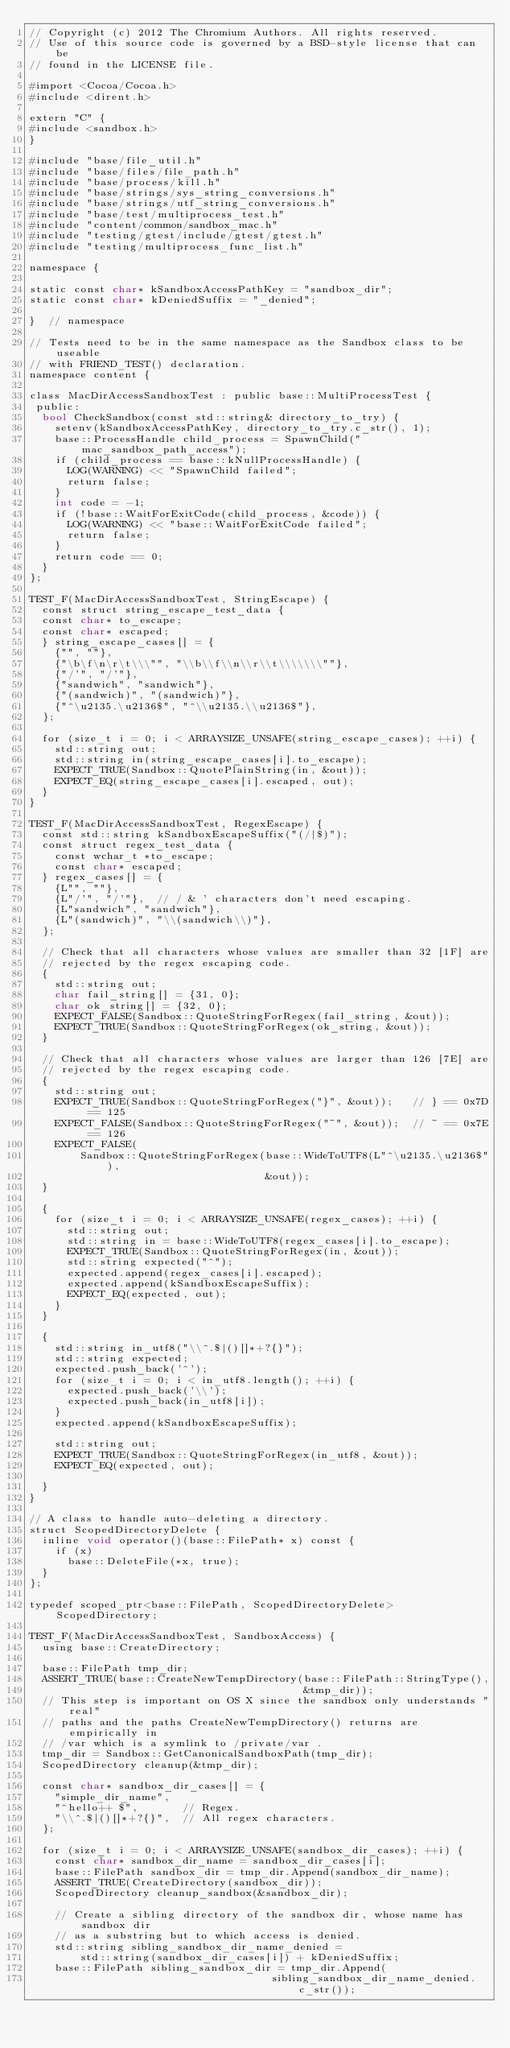Convert code to text. <code><loc_0><loc_0><loc_500><loc_500><_ObjectiveC_>// Copyright (c) 2012 The Chromium Authors. All rights reserved.
// Use of this source code is governed by a BSD-style license that can be
// found in the LICENSE file.

#import <Cocoa/Cocoa.h>
#include <dirent.h>

extern "C" {
#include <sandbox.h>
}

#include "base/file_util.h"
#include "base/files/file_path.h"
#include "base/process/kill.h"
#include "base/strings/sys_string_conversions.h"
#include "base/strings/utf_string_conversions.h"
#include "base/test/multiprocess_test.h"
#include "content/common/sandbox_mac.h"
#include "testing/gtest/include/gtest/gtest.h"
#include "testing/multiprocess_func_list.h"

namespace {

static const char* kSandboxAccessPathKey = "sandbox_dir";
static const char* kDeniedSuffix = "_denied";

}  // namespace

// Tests need to be in the same namespace as the Sandbox class to be useable
// with FRIEND_TEST() declaration.
namespace content {

class MacDirAccessSandboxTest : public base::MultiProcessTest {
 public:
  bool CheckSandbox(const std::string& directory_to_try) {
    setenv(kSandboxAccessPathKey, directory_to_try.c_str(), 1);
    base::ProcessHandle child_process = SpawnChild("mac_sandbox_path_access");
    if (child_process == base::kNullProcessHandle) {
      LOG(WARNING) << "SpawnChild failed";
      return false;
    }
    int code = -1;
    if (!base::WaitForExitCode(child_process, &code)) {
      LOG(WARNING) << "base::WaitForExitCode failed";
      return false;
    }
    return code == 0;
  }
};

TEST_F(MacDirAccessSandboxTest, StringEscape) {
  const struct string_escape_test_data {
  const char* to_escape;
  const char* escaped;
  } string_escape_cases[] = {
    {"", ""},
    {"\b\f\n\r\t\\\"", "\\b\\f\\n\\r\\t\\\\\\\""},
    {"/'", "/'"},
    {"sandwich", "sandwich"},
    {"(sandwich)", "(sandwich)"},
    {"^\u2135.\u2136$", "^\\u2135.\\u2136$"},
  };

  for (size_t i = 0; i < ARRAYSIZE_UNSAFE(string_escape_cases); ++i) {
    std::string out;
    std::string in(string_escape_cases[i].to_escape);
    EXPECT_TRUE(Sandbox::QuotePlainString(in, &out));
    EXPECT_EQ(string_escape_cases[i].escaped, out);
  }
}

TEST_F(MacDirAccessSandboxTest, RegexEscape) {
  const std::string kSandboxEscapeSuffix("(/|$)");
  const struct regex_test_data {
    const wchar_t *to_escape;
    const char* escaped;
  } regex_cases[] = {
    {L"", ""},
    {L"/'", "/'"},  // / & ' characters don't need escaping.
    {L"sandwich", "sandwich"},
    {L"(sandwich)", "\\(sandwich\\)"},
  };

  // Check that all characters whose values are smaller than 32 [1F] are
  // rejected by the regex escaping code.
  {
    std::string out;
    char fail_string[] = {31, 0};
    char ok_string[] = {32, 0};
    EXPECT_FALSE(Sandbox::QuoteStringForRegex(fail_string, &out));
    EXPECT_TRUE(Sandbox::QuoteStringForRegex(ok_string, &out));
  }

  // Check that all characters whose values are larger than 126 [7E] are
  // rejected by the regex escaping code.
  {
    std::string out;
    EXPECT_TRUE(Sandbox::QuoteStringForRegex("}", &out));   // } == 0x7D == 125
    EXPECT_FALSE(Sandbox::QuoteStringForRegex("~", &out));  // ~ == 0x7E == 126
    EXPECT_FALSE(
        Sandbox::QuoteStringForRegex(base::WideToUTF8(L"^\u2135.\u2136$"),
                                     &out));
  }

  {
    for (size_t i = 0; i < ARRAYSIZE_UNSAFE(regex_cases); ++i) {
      std::string out;
      std::string in = base::WideToUTF8(regex_cases[i].to_escape);
      EXPECT_TRUE(Sandbox::QuoteStringForRegex(in, &out));
      std::string expected("^");
      expected.append(regex_cases[i].escaped);
      expected.append(kSandboxEscapeSuffix);
      EXPECT_EQ(expected, out);
    }
  }

  {
    std::string in_utf8("\\^.$|()[]*+?{}");
    std::string expected;
    expected.push_back('^');
    for (size_t i = 0; i < in_utf8.length(); ++i) {
      expected.push_back('\\');
      expected.push_back(in_utf8[i]);
    }
    expected.append(kSandboxEscapeSuffix);

    std::string out;
    EXPECT_TRUE(Sandbox::QuoteStringForRegex(in_utf8, &out));
    EXPECT_EQ(expected, out);

  }
}

// A class to handle auto-deleting a directory.
struct ScopedDirectoryDelete {
  inline void operator()(base::FilePath* x) const {
    if (x)
      base::DeleteFile(*x, true);
  }
};

typedef scoped_ptr<base::FilePath, ScopedDirectoryDelete> ScopedDirectory;

TEST_F(MacDirAccessSandboxTest, SandboxAccess) {
  using base::CreateDirectory;

  base::FilePath tmp_dir;
  ASSERT_TRUE(base::CreateNewTempDirectory(base::FilePath::StringType(),
                                           &tmp_dir));
  // This step is important on OS X since the sandbox only understands "real"
  // paths and the paths CreateNewTempDirectory() returns are empirically in
  // /var which is a symlink to /private/var .
  tmp_dir = Sandbox::GetCanonicalSandboxPath(tmp_dir);
  ScopedDirectory cleanup(&tmp_dir);

  const char* sandbox_dir_cases[] = {
    "simple_dir_name",
    "^hello++ $",       // Regex.
    "\\^.$|()[]*+?{}",  // All regex characters.
  };

  for (size_t i = 0; i < ARRAYSIZE_UNSAFE(sandbox_dir_cases); ++i) {
    const char* sandbox_dir_name = sandbox_dir_cases[i];
    base::FilePath sandbox_dir = tmp_dir.Append(sandbox_dir_name);
    ASSERT_TRUE(CreateDirectory(sandbox_dir));
    ScopedDirectory cleanup_sandbox(&sandbox_dir);

    // Create a sibling directory of the sandbox dir, whose name has sandbox dir
    // as a substring but to which access is denied.
    std::string sibling_sandbox_dir_name_denied =
        std::string(sandbox_dir_cases[i]) + kDeniedSuffix;
    base::FilePath sibling_sandbox_dir = tmp_dir.Append(
                                      sibling_sandbox_dir_name_denied.c_str());</code> 